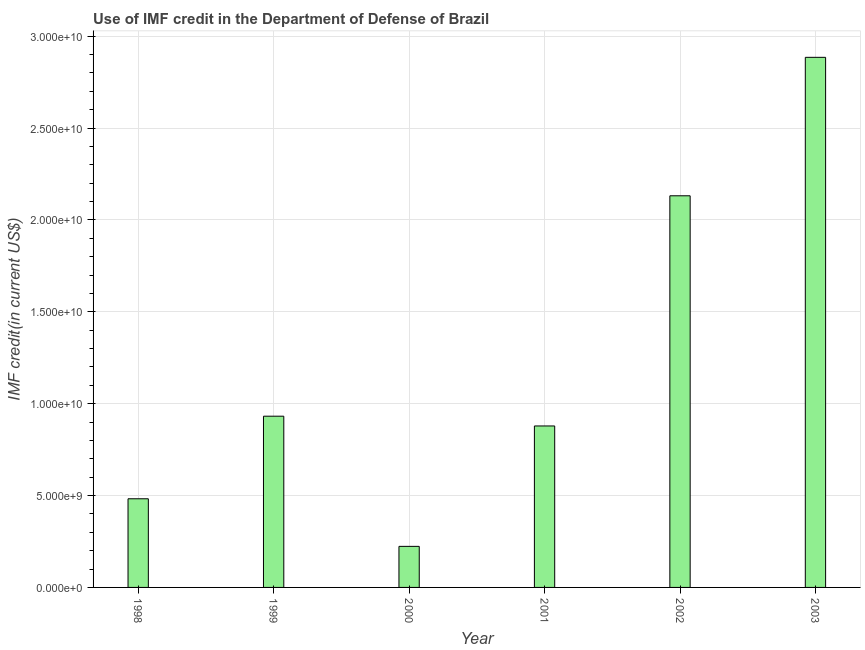What is the title of the graph?
Offer a very short reply. Use of IMF credit in the Department of Defense of Brazil. What is the label or title of the X-axis?
Keep it short and to the point. Year. What is the label or title of the Y-axis?
Your answer should be very brief. IMF credit(in current US$). What is the use of imf credit in dod in 2001?
Your response must be concise. 8.79e+09. Across all years, what is the maximum use of imf credit in dod?
Provide a short and direct response. 2.89e+1. Across all years, what is the minimum use of imf credit in dod?
Your answer should be compact. 2.24e+09. In which year was the use of imf credit in dod maximum?
Provide a succinct answer. 2003. What is the sum of the use of imf credit in dod?
Your answer should be very brief. 7.53e+1. What is the difference between the use of imf credit in dod in 1999 and 2002?
Your response must be concise. -1.20e+1. What is the average use of imf credit in dod per year?
Offer a terse response. 1.26e+1. What is the median use of imf credit in dod?
Keep it short and to the point. 9.05e+09. In how many years, is the use of imf credit in dod greater than 13000000000 US$?
Give a very brief answer. 2. Do a majority of the years between 2002 and 1998 (inclusive) have use of imf credit in dod greater than 26000000000 US$?
Give a very brief answer. Yes. What is the ratio of the use of imf credit in dod in 1998 to that in 2003?
Your answer should be very brief. 0.17. Is the use of imf credit in dod in 1998 less than that in 2003?
Make the answer very short. Yes. Is the difference between the use of imf credit in dod in 1998 and 2001 greater than the difference between any two years?
Provide a succinct answer. No. What is the difference between the highest and the second highest use of imf credit in dod?
Your answer should be compact. 7.54e+09. What is the difference between the highest and the lowest use of imf credit in dod?
Your response must be concise. 2.66e+1. How many bars are there?
Give a very brief answer. 6. Are all the bars in the graph horizontal?
Make the answer very short. No. How many years are there in the graph?
Your answer should be very brief. 6. Are the values on the major ticks of Y-axis written in scientific E-notation?
Give a very brief answer. Yes. What is the IMF credit(in current US$) in 1998?
Your answer should be very brief. 4.83e+09. What is the IMF credit(in current US$) of 1999?
Make the answer very short. 9.32e+09. What is the IMF credit(in current US$) in 2000?
Offer a very short reply. 2.24e+09. What is the IMF credit(in current US$) in 2001?
Provide a short and direct response. 8.79e+09. What is the IMF credit(in current US$) of 2002?
Keep it short and to the point. 2.13e+1. What is the IMF credit(in current US$) in 2003?
Your answer should be very brief. 2.89e+1. What is the difference between the IMF credit(in current US$) in 1998 and 1999?
Keep it short and to the point. -4.49e+09. What is the difference between the IMF credit(in current US$) in 1998 and 2000?
Offer a very short reply. 2.59e+09. What is the difference between the IMF credit(in current US$) in 1998 and 2001?
Give a very brief answer. -3.96e+09. What is the difference between the IMF credit(in current US$) in 1998 and 2002?
Provide a short and direct response. -1.65e+1. What is the difference between the IMF credit(in current US$) in 1998 and 2003?
Provide a succinct answer. -2.40e+1. What is the difference between the IMF credit(in current US$) in 1999 and 2000?
Provide a succinct answer. 7.08e+09. What is the difference between the IMF credit(in current US$) in 1999 and 2001?
Offer a very short reply. 5.31e+08. What is the difference between the IMF credit(in current US$) in 1999 and 2002?
Keep it short and to the point. -1.20e+1. What is the difference between the IMF credit(in current US$) in 1999 and 2003?
Your answer should be very brief. -1.95e+1. What is the difference between the IMF credit(in current US$) in 2000 and 2001?
Keep it short and to the point. -6.55e+09. What is the difference between the IMF credit(in current US$) in 2000 and 2002?
Provide a short and direct response. -1.91e+1. What is the difference between the IMF credit(in current US$) in 2000 and 2003?
Offer a very short reply. -2.66e+1. What is the difference between the IMF credit(in current US$) in 2001 and 2002?
Offer a very short reply. -1.25e+1. What is the difference between the IMF credit(in current US$) in 2001 and 2003?
Offer a very short reply. -2.01e+1. What is the difference between the IMF credit(in current US$) in 2002 and 2003?
Provide a short and direct response. -7.54e+09. What is the ratio of the IMF credit(in current US$) in 1998 to that in 1999?
Offer a very short reply. 0.52. What is the ratio of the IMF credit(in current US$) in 1998 to that in 2000?
Offer a very short reply. 2.16. What is the ratio of the IMF credit(in current US$) in 1998 to that in 2001?
Your answer should be compact. 0.55. What is the ratio of the IMF credit(in current US$) in 1998 to that in 2002?
Ensure brevity in your answer.  0.23. What is the ratio of the IMF credit(in current US$) in 1998 to that in 2003?
Provide a succinct answer. 0.17. What is the ratio of the IMF credit(in current US$) in 1999 to that in 2000?
Keep it short and to the point. 4.17. What is the ratio of the IMF credit(in current US$) in 1999 to that in 2001?
Make the answer very short. 1.06. What is the ratio of the IMF credit(in current US$) in 1999 to that in 2002?
Provide a succinct answer. 0.44. What is the ratio of the IMF credit(in current US$) in 1999 to that in 2003?
Provide a succinct answer. 0.32. What is the ratio of the IMF credit(in current US$) in 2000 to that in 2001?
Provide a succinct answer. 0.25. What is the ratio of the IMF credit(in current US$) in 2000 to that in 2002?
Your response must be concise. 0.1. What is the ratio of the IMF credit(in current US$) in 2000 to that in 2003?
Your answer should be very brief. 0.08. What is the ratio of the IMF credit(in current US$) in 2001 to that in 2002?
Ensure brevity in your answer.  0.41. What is the ratio of the IMF credit(in current US$) in 2001 to that in 2003?
Keep it short and to the point. 0.3. What is the ratio of the IMF credit(in current US$) in 2002 to that in 2003?
Give a very brief answer. 0.74. 